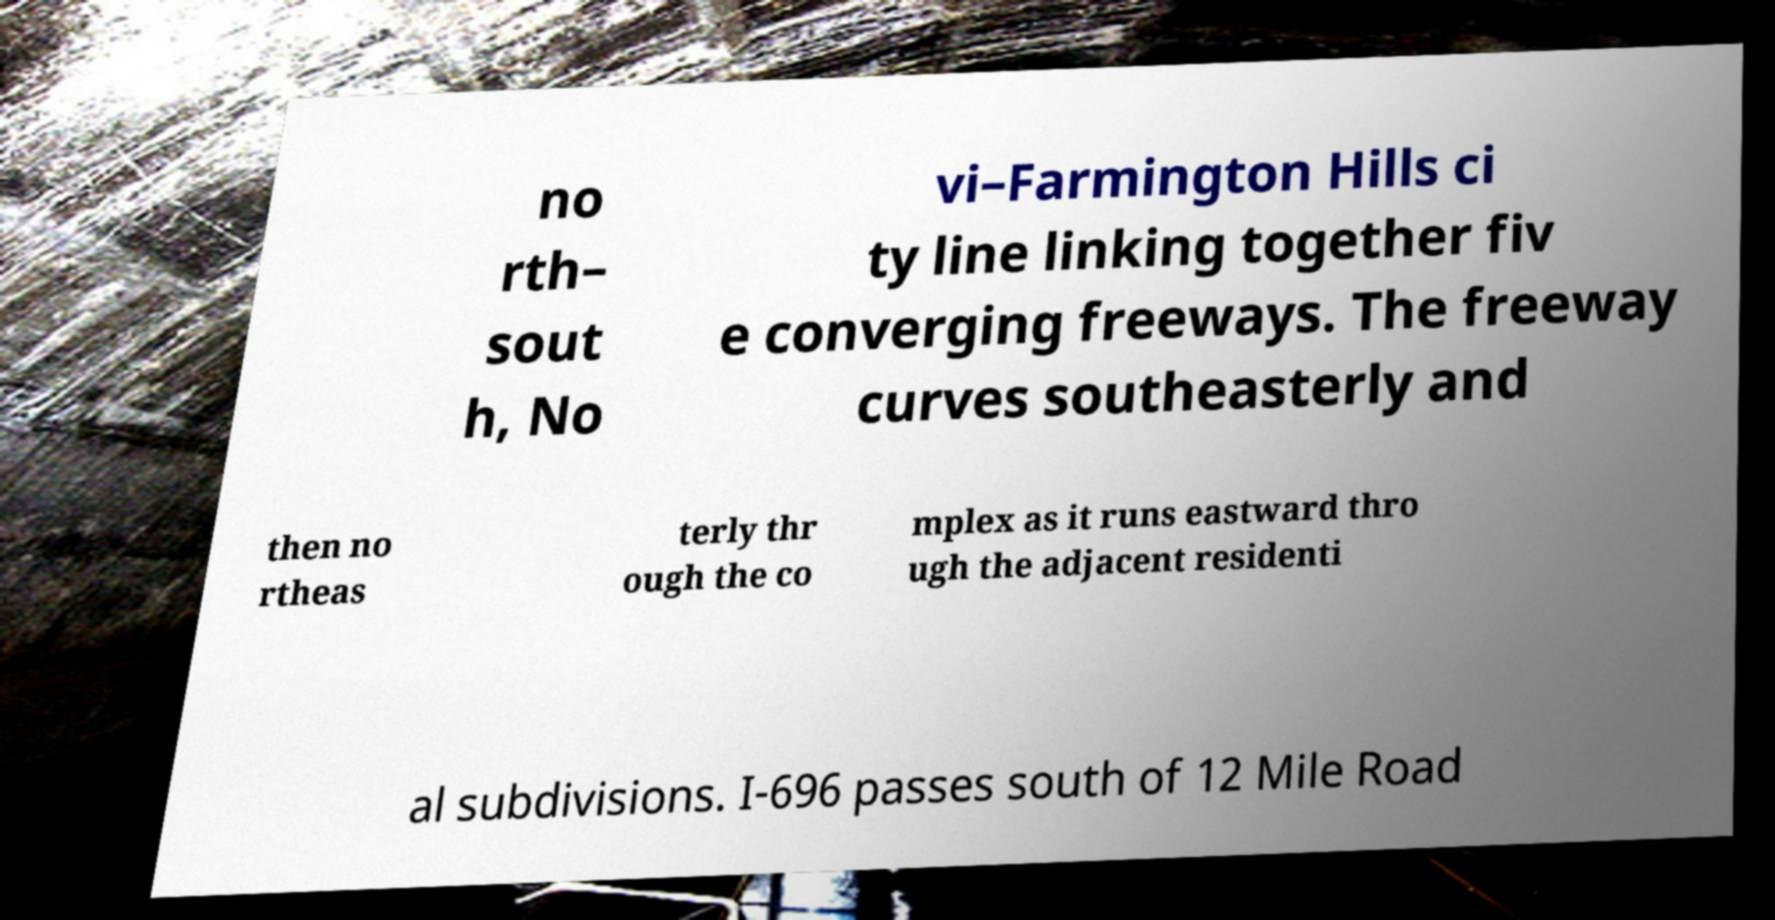Could you assist in decoding the text presented in this image and type it out clearly? no rth– sout h, No vi–Farmington Hills ci ty line linking together fiv e converging freeways. The freeway curves southeasterly and then no rtheas terly thr ough the co mplex as it runs eastward thro ugh the adjacent residenti al subdivisions. I-696 passes south of 12 Mile Road 